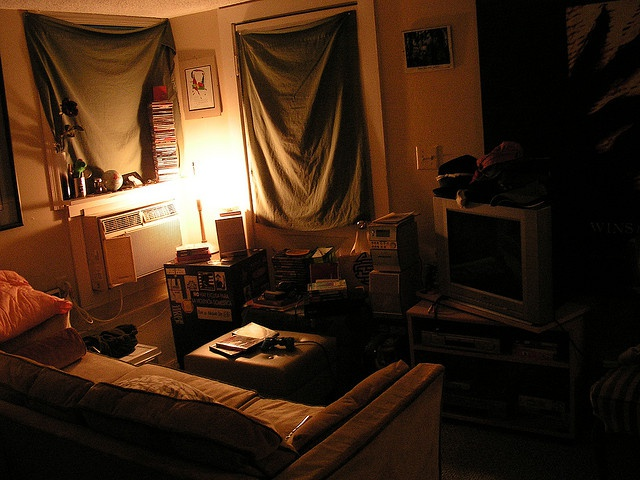Describe the objects in this image and their specific colors. I can see couch in brown, black, and maroon tones, tv in brown, black, and maroon tones, book in brown, tan, maroon, and ivory tones, book in brown, black, maroon, and tan tones, and book in brown, khaki, tan, and red tones in this image. 